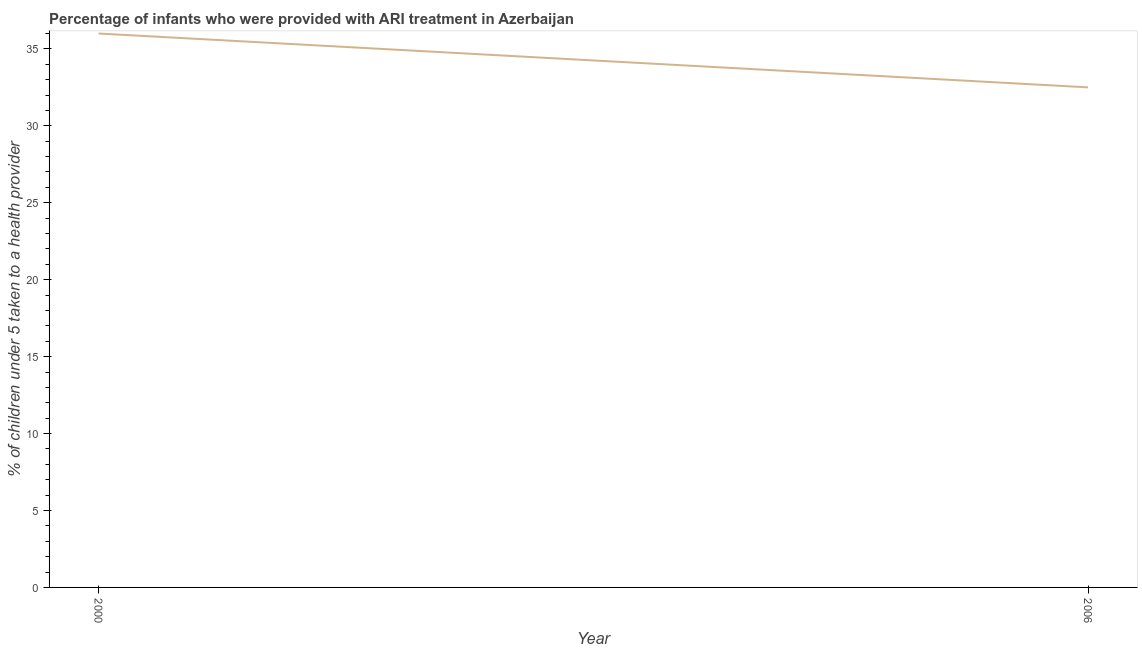What is the percentage of children who were provided with ari treatment in 2006?
Offer a terse response. 32.5. Across all years, what is the maximum percentage of children who were provided with ari treatment?
Keep it short and to the point. 36. Across all years, what is the minimum percentage of children who were provided with ari treatment?
Your response must be concise. 32.5. In which year was the percentage of children who were provided with ari treatment minimum?
Give a very brief answer. 2006. What is the sum of the percentage of children who were provided with ari treatment?
Keep it short and to the point. 68.5. What is the difference between the percentage of children who were provided with ari treatment in 2000 and 2006?
Provide a short and direct response. 3.5. What is the average percentage of children who were provided with ari treatment per year?
Make the answer very short. 34.25. What is the median percentage of children who were provided with ari treatment?
Your response must be concise. 34.25. What is the ratio of the percentage of children who were provided with ari treatment in 2000 to that in 2006?
Keep it short and to the point. 1.11. Is the percentage of children who were provided with ari treatment in 2000 less than that in 2006?
Your response must be concise. No. In how many years, is the percentage of children who were provided with ari treatment greater than the average percentage of children who were provided with ari treatment taken over all years?
Ensure brevity in your answer.  1. How many lines are there?
Your answer should be compact. 1. Are the values on the major ticks of Y-axis written in scientific E-notation?
Ensure brevity in your answer.  No. Does the graph contain any zero values?
Provide a short and direct response. No. Does the graph contain grids?
Your answer should be very brief. No. What is the title of the graph?
Ensure brevity in your answer.  Percentage of infants who were provided with ARI treatment in Azerbaijan. What is the label or title of the Y-axis?
Give a very brief answer. % of children under 5 taken to a health provider. What is the % of children under 5 taken to a health provider in 2006?
Give a very brief answer. 32.5. What is the ratio of the % of children under 5 taken to a health provider in 2000 to that in 2006?
Your answer should be compact. 1.11. 